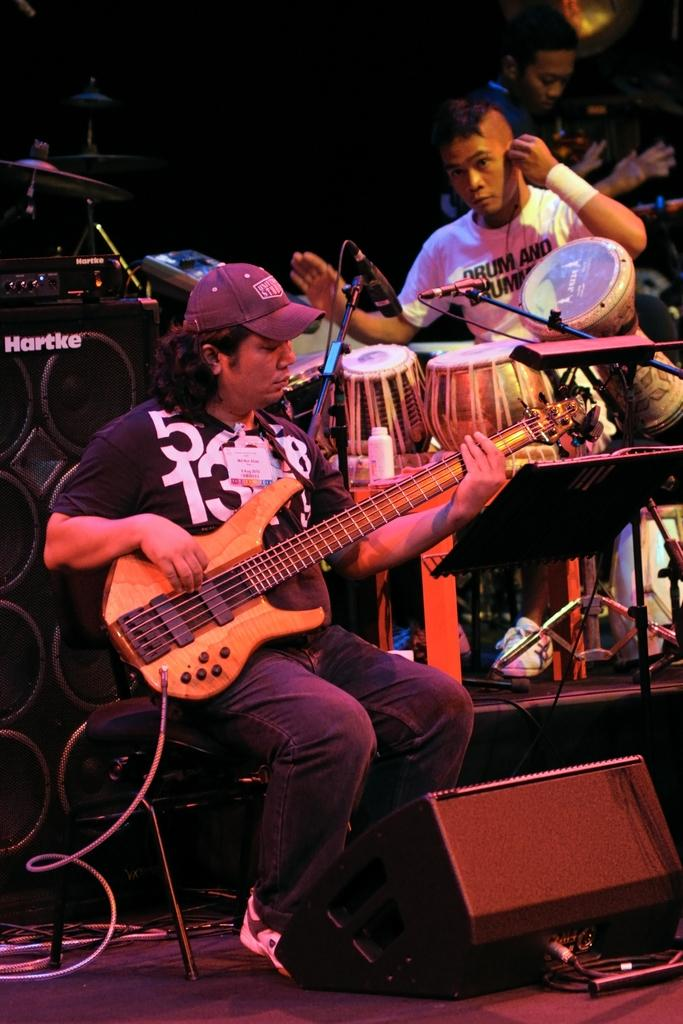How many people are in the image? There are 3 people in the image. What are the people at the front and center doing? The person at the front is playing a guitar, and the person at the center is playing drums. What is the position of the person at the back? The person at the back is standing. Where are the speakers located in the image? The speakers are on the left side of the image. What type of advertisement can be seen on the drum set in the image? There is no advertisement visible on the drum set in the image. How many roses are being held by the person playing the guitar? There are no roses present in the image. 